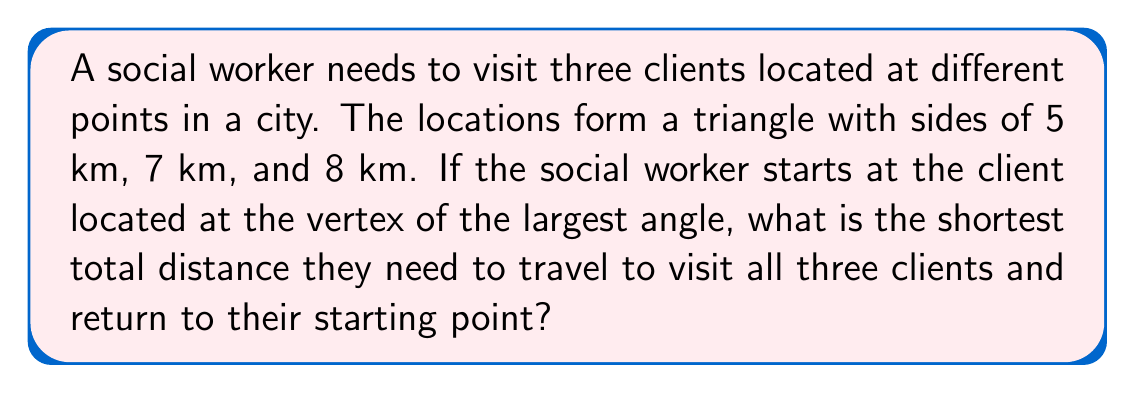Solve this math problem. To solve this problem, we'll use the law of cosines and some trigonometric concepts:

1) First, we need to find the largest angle in the triangle. We can use the law of cosines:

   $c^2 = a^2 + b^2 - 2ab \cos(C)$

   Where $c$ is the longest side (8 km), and $a$ and $b$ are the other two sides (5 km and 7 km).

2) Rearranging the formula to solve for $\cos(C)$:

   $\cos(C) = \frac{a^2 + b^2 - c^2}{2ab}$

3) Substituting the values:

   $\cos(C) = \frac{5^2 + 7^2 - 8^2}{2(5)(7)} = \frac{25 + 49 - 64}{70} = \frac{10}{70} = \frac{1}{7}$

4) Taking the inverse cosine:

   $C = \arccos(\frac{1}{7}) \approx 1.4457$ radians or about 82.82°

5) This is indeed the largest angle in the triangle.

6) The most efficient route would be to start at this vertex, visit the other two clients, and return. This forms an isosceles triangle where two sides are equal to the perimeter of the original triangle.

7) The perimeter of the original triangle is:

   $5 + 7 + 8 = 20$ km

8) So the total distance traveled is:

   $20 + 20 = 40$ km

Therefore, the shortest total distance the social worker needs to travel is 40 km.
Answer: 40 km 